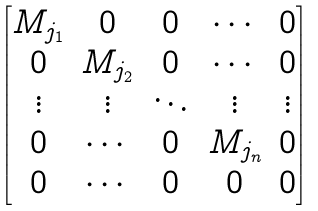<formula> <loc_0><loc_0><loc_500><loc_500>\begin{bmatrix} M _ { j _ { 1 } } & 0 & 0 & \cdots & 0 \\ 0 & M _ { j _ { 2 } } & 0 & \cdots & 0 \\ \vdots & \vdots & \ddots & \vdots & \vdots \\ 0 & \cdots & 0 & M _ { j _ { n } } & 0 \\ 0 & \cdots & 0 & 0 & 0 \end{bmatrix}</formula> 